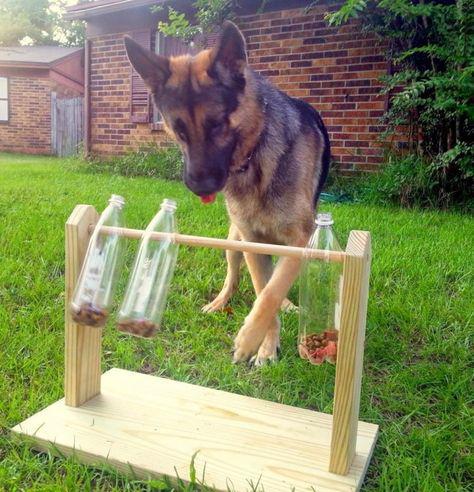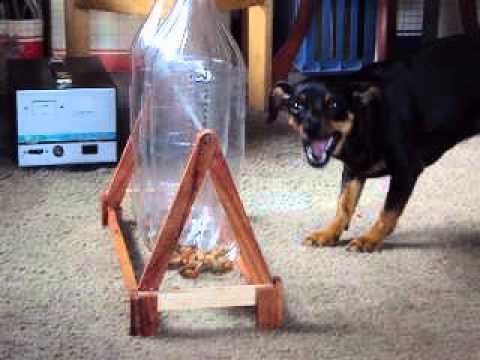The first image is the image on the left, the second image is the image on the right. Given the left and right images, does the statement "An image shows a cat crouched behind a bottle trimmed with blue curly ribbon." hold true? Answer yes or no. No. The first image is the image on the left, the second image is the image on the right. Considering the images on both sides, is "A cat is rolling a bottle on the floor in one of the images." valid? Answer yes or no. No. 